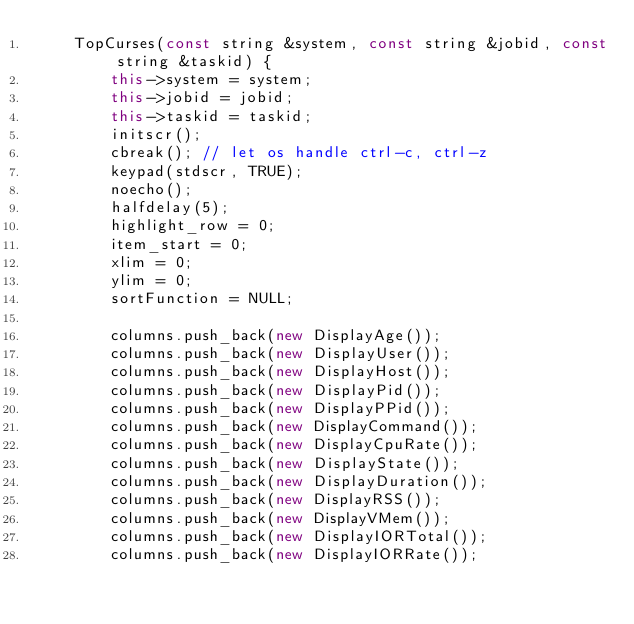<code> <loc_0><loc_0><loc_500><loc_500><_C++_>    TopCurses(const string &system, const string &jobid, const string &taskid) {
        this->system = system;
        this->jobid = jobid;
        this->taskid = taskid;
        initscr();
        cbreak(); // let os handle ctrl-c, ctrl-z
        keypad(stdscr, TRUE);
        noecho();
        halfdelay(5);
        highlight_row = 0;
        item_start = 0;
        xlim = 0;
        ylim = 0;
        sortFunction = NULL;

        columns.push_back(new DisplayAge());
        columns.push_back(new DisplayUser());
        columns.push_back(new DisplayHost());
        columns.push_back(new DisplayPid());
        columns.push_back(new DisplayPPid());
        columns.push_back(new DisplayCommand());
        columns.push_back(new DisplayCpuRate());
        columns.push_back(new DisplayState());
        columns.push_back(new DisplayDuration());
        columns.push_back(new DisplayRSS());
        columns.push_back(new DisplayVMem());
        columns.push_back(new DisplayIORTotal());
        columns.push_back(new DisplayIORRate());</code> 